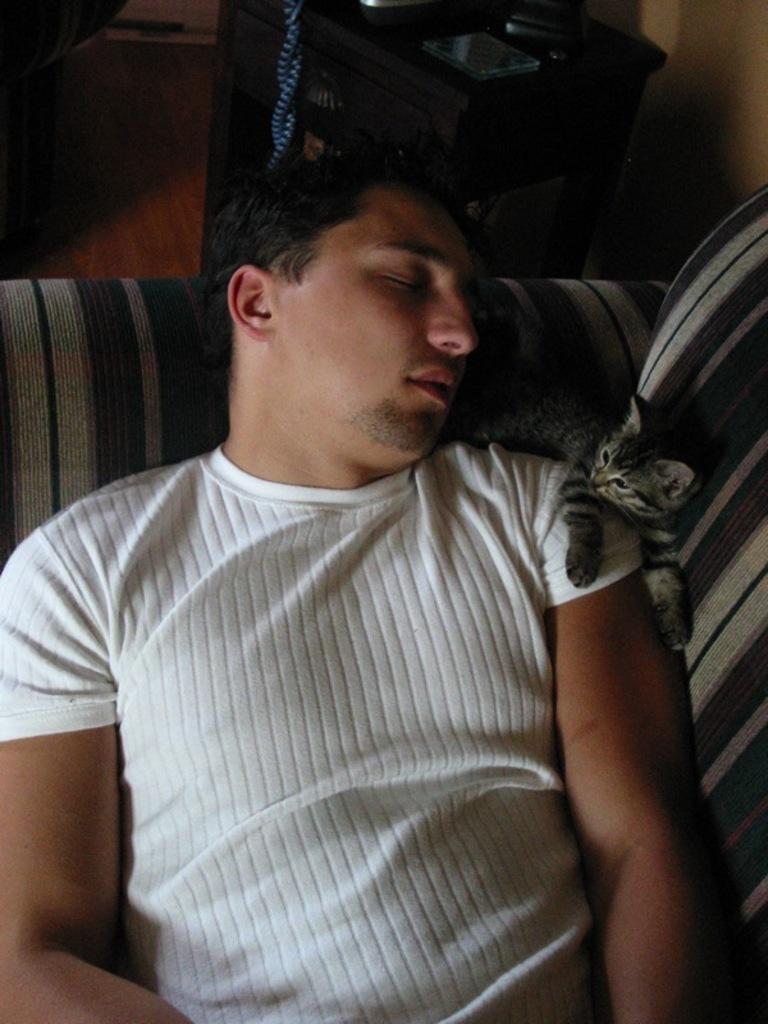How would you summarize this image in a sentence or two? In this image there is a man sleeping in a couch and there is a cat , table , book. 